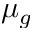Convert formula to latex. <formula><loc_0><loc_0><loc_500><loc_500>\mu _ { g }</formula> 